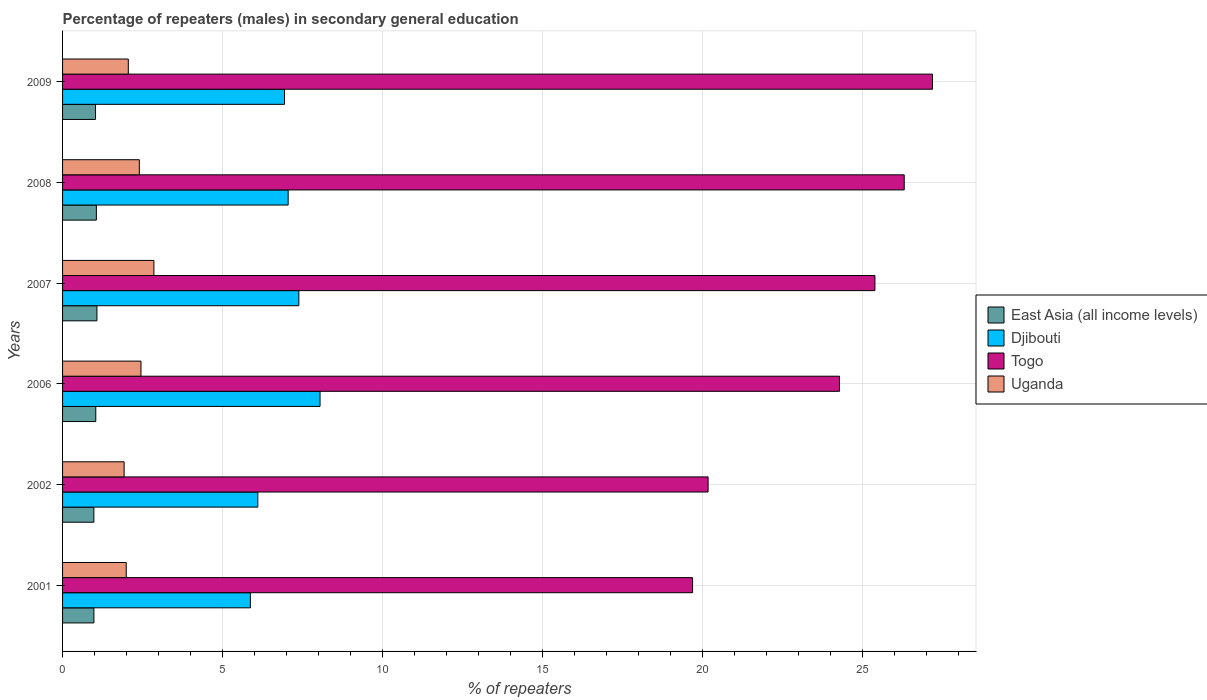How many groups of bars are there?
Offer a terse response. 6. Are the number of bars per tick equal to the number of legend labels?
Provide a short and direct response. Yes. Are the number of bars on each tick of the Y-axis equal?
Your answer should be compact. Yes. How many bars are there on the 2nd tick from the bottom?
Make the answer very short. 4. What is the percentage of male repeaters in East Asia (all income levels) in 2009?
Your response must be concise. 1.03. Across all years, what is the maximum percentage of male repeaters in Togo?
Ensure brevity in your answer.  27.2. Across all years, what is the minimum percentage of male repeaters in Djibouti?
Provide a succinct answer. 5.87. In which year was the percentage of male repeaters in Uganda maximum?
Provide a succinct answer. 2007. What is the total percentage of male repeaters in Togo in the graph?
Provide a short and direct response. 143.08. What is the difference between the percentage of male repeaters in East Asia (all income levels) in 2002 and that in 2006?
Provide a succinct answer. -0.06. What is the difference between the percentage of male repeaters in Togo in 2007 and the percentage of male repeaters in Uganda in 2001?
Offer a very short reply. 23.41. What is the average percentage of male repeaters in Uganda per year?
Your answer should be compact. 2.28. In the year 2001, what is the difference between the percentage of male repeaters in Djibouti and percentage of male repeaters in Uganda?
Offer a very short reply. 3.88. In how many years, is the percentage of male repeaters in Djibouti greater than 1 %?
Give a very brief answer. 6. What is the ratio of the percentage of male repeaters in East Asia (all income levels) in 2001 to that in 2006?
Make the answer very short. 0.94. What is the difference between the highest and the second highest percentage of male repeaters in East Asia (all income levels)?
Your answer should be compact. 0.02. What is the difference between the highest and the lowest percentage of male repeaters in Uganda?
Your response must be concise. 0.93. What does the 1st bar from the top in 2008 represents?
Ensure brevity in your answer.  Uganda. What does the 4th bar from the bottom in 2002 represents?
Make the answer very short. Uganda. Is it the case that in every year, the sum of the percentage of male repeaters in East Asia (all income levels) and percentage of male repeaters in Uganda is greater than the percentage of male repeaters in Togo?
Provide a succinct answer. No. How many bars are there?
Give a very brief answer. 24. What is the difference between two consecutive major ticks on the X-axis?
Your answer should be very brief. 5. Are the values on the major ticks of X-axis written in scientific E-notation?
Your response must be concise. No. Does the graph contain any zero values?
Provide a short and direct response. No. Does the graph contain grids?
Give a very brief answer. Yes. Where does the legend appear in the graph?
Keep it short and to the point. Center right. How are the legend labels stacked?
Offer a terse response. Vertical. What is the title of the graph?
Your response must be concise. Percentage of repeaters (males) in secondary general education. Does "India" appear as one of the legend labels in the graph?
Your response must be concise. No. What is the label or title of the X-axis?
Give a very brief answer. % of repeaters. What is the % of repeaters in East Asia (all income levels) in 2001?
Offer a very short reply. 0.98. What is the % of repeaters of Djibouti in 2001?
Your answer should be compact. 5.87. What is the % of repeaters of Togo in 2001?
Your response must be concise. 19.7. What is the % of repeaters in Uganda in 2001?
Provide a succinct answer. 1.99. What is the % of repeaters in East Asia (all income levels) in 2002?
Your answer should be very brief. 0.98. What is the % of repeaters in Djibouti in 2002?
Make the answer very short. 6.1. What is the % of repeaters of Togo in 2002?
Provide a short and direct response. 20.18. What is the % of repeaters of Uganda in 2002?
Your answer should be compact. 1.92. What is the % of repeaters of East Asia (all income levels) in 2006?
Provide a short and direct response. 1.04. What is the % of repeaters in Djibouti in 2006?
Make the answer very short. 8.05. What is the % of repeaters in Togo in 2006?
Make the answer very short. 24.29. What is the % of repeaters of Uganda in 2006?
Provide a short and direct response. 2.45. What is the % of repeaters of East Asia (all income levels) in 2007?
Provide a succinct answer. 1.07. What is the % of repeaters in Djibouti in 2007?
Make the answer very short. 7.39. What is the % of repeaters of Togo in 2007?
Your answer should be compact. 25.4. What is the % of repeaters in Uganda in 2007?
Provide a succinct answer. 2.86. What is the % of repeaters of East Asia (all income levels) in 2008?
Give a very brief answer. 1.06. What is the % of repeaters in Djibouti in 2008?
Offer a terse response. 7.05. What is the % of repeaters in Togo in 2008?
Your answer should be compact. 26.31. What is the % of repeaters in Uganda in 2008?
Your response must be concise. 2.4. What is the % of repeaters in East Asia (all income levels) in 2009?
Make the answer very short. 1.03. What is the % of repeaters in Djibouti in 2009?
Your response must be concise. 6.94. What is the % of repeaters in Togo in 2009?
Keep it short and to the point. 27.2. What is the % of repeaters of Uganda in 2009?
Ensure brevity in your answer.  2.06. Across all years, what is the maximum % of repeaters in East Asia (all income levels)?
Provide a succinct answer. 1.07. Across all years, what is the maximum % of repeaters in Djibouti?
Your response must be concise. 8.05. Across all years, what is the maximum % of repeaters in Togo?
Give a very brief answer. 27.2. Across all years, what is the maximum % of repeaters in Uganda?
Keep it short and to the point. 2.86. Across all years, what is the minimum % of repeaters in East Asia (all income levels)?
Your answer should be very brief. 0.98. Across all years, what is the minimum % of repeaters of Djibouti?
Your answer should be compact. 5.87. Across all years, what is the minimum % of repeaters in Togo?
Give a very brief answer. 19.7. Across all years, what is the minimum % of repeaters in Uganda?
Give a very brief answer. 1.92. What is the total % of repeaters in East Asia (all income levels) in the graph?
Your answer should be very brief. 6.16. What is the total % of repeaters of Djibouti in the graph?
Provide a succinct answer. 41.41. What is the total % of repeaters in Togo in the graph?
Give a very brief answer. 143.08. What is the total % of repeaters in Uganda in the graph?
Offer a terse response. 13.68. What is the difference between the % of repeaters in East Asia (all income levels) in 2001 and that in 2002?
Offer a terse response. 0. What is the difference between the % of repeaters of Djibouti in 2001 and that in 2002?
Offer a terse response. -0.23. What is the difference between the % of repeaters in Togo in 2001 and that in 2002?
Make the answer very short. -0.48. What is the difference between the % of repeaters in Uganda in 2001 and that in 2002?
Make the answer very short. 0.07. What is the difference between the % of repeaters of East Asia (all income levels) in 2001 and that in 2006?
Your response must be concise. -0.06. What is the difference between the % of repeaters of Djibouti in 2001 and that in 2006?
Keep it short and to the point. -2.18. What is the difference between the % of repeaters in Togo in 2001 and that in 2006?
Your response must be concise. -4.59. What is the difference between the % of repeaters of Uganda in 2001 and that in 2006?
Your answer should be very brief. -0.46. What is the difference between the % of repeaters in East Asia (all income levels) in 2001 and that in 2007?
Your response must be concise. -0.1. What is the difference between the % of repeaters of Djibouti in 2001 and that in 2007?
Provide a short and direct response. -1.51. What is the difference between the % of repeaters in Togo in 2001 and that in 2007?
Provide a short and direct response. -5.7. What is the difference between the % of repeaters of Uganda in 2001 and that in 2007?
Ensure brevity in your answer.  -0.87. What is the difference between the % of repeaters in East Asia (all income levels) in 2001 and that in 2008?
Your answer should be very brief. -0.08. What is the difference between the % of repeaters of Djibouti in 2001 and that in 2008?
Provide a succinct answer. -1.18. What is the difference between the % of repeaters in Togo in 2001 and that in 2008?
Keep it short and to the point. -6.62. What is the difference between the % of repeaters in Uganda in 2001 and that in 2008?
Keep it short and to the point. -0.41. What is the difference between the % of repeaters of East Asia (all income levels) in 2001 and that in 2009?
Your answer should be compact. -0.05. What is the difference between the % of repeaters of Djibouti in 2001 and that in 2009?
Your response must be concise. -1.07. What is the difference between the % of repeaters in Togo in 2001 and that in 2009?
Make the answer very short. -7.5. What is the difference between the % of repeaters of Uganda in 2001 and that in 2009?
Provide a short and direct response. -0.06. What is the difference between the % of repeaters in East Asia (all income levels) in 2002 and that in 2006?
Your response must be concise. -0.06. What is the difference between the % of repeaters in Djibouti in 2002 and that in 2006?
Ensure brevity in your answer.  -1.95. What is the difference between the % of repeaters of Togo in 2002 and that in 2006?
Give a very brief answer. -4.11. What is the difference between the % of repeaters in Uganda in 2002 and that in 2006?
Offer a terse response. -0.53. What is the difference between the % of repeaters of East Asia (all income levels) in 2002 and that in 2007?
Give a very brief answer. -0.1. What is the difference between the % of repeaters in Djibouti in 2002 and that in 2007?
Give a very brief answer. -1.28. What is the difference between the % of repeaters in Togo in 2002 and that in 2007?
Ensure brevity in your answer.  -5.22. What is the difference between the % of repeaters of Uganda in 2002 and that in 2007?
Offer a very short reply. -0.93. What is the difference between the % of repeaters in East Asia (all income levels) in 2002 and that in 2008?
Give a very brief answer. -0.08. What is the difference between the % of repeaters in Djibouti in 2002 and that in 2008?
Your answer should be compact. -0.95. What is the difference between the % of repeaters of Togo in 2002 and that in 2008?
Keep it short and to the point. -6.13. What is the difference between the % of repeaters in Uganda in 2002 and that in 2008?
Make the answer very short. -0.47. What is the difference between the % of repeaters in East Asia (all income levels) in 2002 and that in 2009?
Provide a short and direct response. -0.05. What is the difference between the % of repeaters of Djibouti in 2002 and that in 2009?
Your response must be concise. -0.84. What is the difference between the % of repeaters of Togo in 2002 and that in 2009?
Offer a terse response. -7.02. What is the difference between the % of repeaters in Uganda in 2002 and that in 2009?
Offer a very short reply. -0.13. What is the difference between the % of repeaters in East Asia (all income levels) in 2006 and that in 2007?
Your answer should be very brief. -0.04. What is the difference between the % of repeaters of Djibouti in 2006 and that in 2007?
Ensure brevity in your answer.  0.66. What is the difference between the % of repeaters in Togo in 2006 and that in 2007?
Give a very brief answer. -1.11. What is the difference between the % of repeaters of Uganda in 2006 and that in 2007?
Ensure brevity in your answer.  -0.4. What is the difference between the % of repeaters in East Asia (all income levels) in 2006 and that in 2008?
Your response must be concise. -0.02. What is the difference between the % of repeaters of Togo in 2006 and that in 2008?
Keep it short and to the point. -2.02. What is the difference between the % of repeaters in Uganda in 2006 and that in 2008?
Your answer should be very brief. 0.05. What is the difference between the % of repeaters of East Asia (all income levels) in 2006 and that in 2009?
Give a very brief answer. 0.01. What is the difference between the % of repeaters in Djibouti in 2006 and that in 2009?
Offer a terse response. 1.11. What is the difference between the % of repeaters in Togo in 2006 and that in 2009?
Your answer should be very brief. -2.91. What is the difference between the % of repeaters in Uganda in 2006 and that in 2009?
Make the answer very short. 0.4. What is the difference between the % of repeaters in East Asia (all income levels) in 2007 and that in 2008?
Provide a short and direct response. 0.02. What is the difference between the % of repeaters in Djibouti in 2007 and that in 2008?
Your answer should be compact. 0.33. What is the difference between the % of repeaters of Togo in 2007 and that in 2008?
Ensure brevity in your answer.  -0.92. What is the difference between the % of repeaters in Uganda in 2007 and that in 2008?
Make the answer very short. 0.46. What is the difference between the % of repeaters in East Asia (all income levels) in 2007 and that in 2009?
Give a very brief answer. 0.04. What is the difference between the % of repeaters in Djibouti in 2007 and that in 2009?
Give a very brief answer. 0.45. What is the difference between the % of repeaters in Togo in 2007 and that in 2009?
Keep it short and to the point. -1.8. What is the difference between the % of repeaters of Uganda in 2007 and that in 2009?
Provide a short and direct response. 0.8. What is the difference between the % of repeaters in East Asia (all income levels) in 2008 and that in 2009?
Your answer should be very brief. 0.03. What is the difference between the % of repeaters of Djibouti in 2008 and that in 2009?
Provide a succinct answer. 0.11. What is the difference between the % of repeaters of Togo in 2008 and that in 2009?
Make the answer very short. -0.88. What is the difference between the % of repeaters in Uganda in 2008 and that in 2009?
Your answer should be very brief. 0.34. What is the difference between the % of repeaters in East Asia (all income levels) in 2001 and the % of repeaters in Djibouti in 2002?
Your answer should be very brief. -5.13. What is the difference between the % of repeaters in East Asia (all income levels) in 2001 and the % of repeaters in Togo in 2002?
Give a very brief answer. -19.2. What is the difference between the % of repeaters of East Asia (all income levels) in 2001 and the % of repeaters of Uganda in 2002?
Provide a short and direct response. -0.95. What is the difference between the % of repeaters of Djibouti in 2001 and the % of repeaters of Togo in 2002?
Your answer should be very brief. -14.31. What is the difference between the % of repeaters of Djibouti in 2001 and the % of repeaters of Uganda in 2002?
Make the answer very short. 3.95. What is the difference between the % of repeaters of Togo in 2001 and the % of repeaters of Uganda in 2002?
Your response must be concise. 17.77. What is the difference between the % of repeaters of East Asia (all income levels) in 2001 and the % of repeaters of Djibouti in 2006?
Keep it short and to the point. -7.07. What is the difference between the % of repeaters in East Asia (all income levels) in 2001 and the % of repeaters in Togo in 2006?
Offer a terse response. -23.31. What is the difference between the % of repeaters in East Asia (all income levels) in 2001 and the % of repeaters in Uganda in 2006?
Offer a very short reply. -1.47. What is the difference between the % of repeaters in Djibouti in 2001 and the % of repeaters in Togo in 2006?
Keep it short and to the point. -18.42. What is the difference between the % of repeaters of Djibouti in 2001 and the % of repeaters of Uganda in 2006?
Keep it short and to the point. 3.42. What is the difference between the % of repeaters in Togo in 2001 and the % of repeaters in Uganda in 2006?
Offer a very short reply. 17.25. What is the difference between the % of repeaters in East Asia (all income levels) in 2001 and the % of repeaters in Djibouti in 2007?
Your response must be concise. -6.41. What is the difference between the % of repeaters of East Asia (all income levels) in 2001 and the % of repeaters of Togo in 2007?
Your response must be concise. -24.42. What is the difference between the % of repeaters of East Asia (all income levels) in 2001 and the % of repeaters of Uganda in 2007?
Your answer should be compact. -1.88. What is the difference between the % of repeaters in Djibouti in 2001 and the % of repeaters in Togo in 2007?
Offer a terse response. -19.53. What is the difference between the % of repeaters of Djibouti in 2001 and the % of repeaters of Uganda in 2007?
Make the answer very short. 3.02. What is the difference between the % of repeaters in Togo in 2001 and the % of repeaters in Uganda in 2007?
Your answer should be compact. 16.84. What is the difference between the % of repeaters of East Asia (all income levels) in 2001 and the % of repeaters of Djibouti in 2008?
Your response must be concise. -6.07. What is the difference between the % of repeaters in East Asia (all income levels) in 2001 and the % of repeaters in Togo in 2008?
Make the answer very short. -25.33. What is the difference between the % of repeaters in East Asia (all income levels) in 2001 and the % of repeaters in Uganda in 2008?
Ensure brevity in your answer.  -1.42. What is the difference between the % of repeaters of Djibouti in 2001 and the % of repeaters of Togo in 2008?
Your answer should be compact. -20.44. What is the difference between the % of repeaters in Djibouti in 2001 and the % of repeaters in Uganda in 2008?
Give a very brief answer. 3.47. What is the difference between the % of repeaters of Togo in 2001 and the % of repeaters of Uganda in 2008?
Your answer should be very brief. 17.3. What is the difference between the % of repeaters in East Asia (all income levels) in 2001 and the % of repeaters in Djibouti in 2009?
Your answer should be compact. -5.96. What is the difference between the % of repeaters in East Asia (all income levels) in 2001 and the % of repeaters in Togo in 2009?
Offer a terse response. -26.22. What is the difference between the % of repeaters in East Asia (all income levels) in 2001 and the % of repeaters in Uganda in 2009?
Offer a very short reply. -1.08. What is the difference between the % of repeaters in Djibouti in 2001 and the % of repeaters in Togo in 2009?
Provide a short and direct response. -21.33. What is the difference between the % of repeaters of Djibouti in 2001 and the % of repeaters of Uganda in 2009?
Give a very brief answer. 3.82. What is the difference between the % of repeaters of Togo in 2001 and the % of repeaters of Uganda in 2009?
Provide a short and direct response. 17.64. What is the difference between the % of repeaters in East Asia (all income levels) in 2002 and the % of repeaters in Djibouti in 2006?
Your response must be concise. -7.07. What is the difference between the % of repeaters of East Asia (all income levels) in 2002 and the % of repeaters of Togo in 2006?
Your response must be concise. -23.31. What is the difference between the % of repeaters in East Asia (all income levels) in 2002 and the % of repeaters in Uganda in 2006?
Offer a terse response. -1.47. What is the difference between the % of repeaters of Djibouti in 2002 and the % of repeaters of Togo in 2006?
Give a very brief answer. -18.19. What is the difference between the % of repeaters in Djibouti in 2002 and the % of repeaters in Uganda in 2006?
Keep it short and to the point. 3.65. What is the difference between the % of repeaters in Togo in 2002 and the % of repeaters in Uganda in 2006?
Your response must be concise. 17.73. What is the difference between the % of repeaters in East Asia (all income levels) in 2002 and the % of repeaters in Djibouti in 2007?
Keep it short and to the point. -6.41. What is the difference between the % of repeaters of East Asia (all income levels) in 2002 and the % of repeaters of Togo in 2007?
Your response must be concise. -24.42. What is the difference between the % of repeaters in East Asia (all income levels) in 2002 and the % of repeaters in Uganda in 2007?
Ensure brevity in your answer.  -1.88. What is the difference between the % of repeaters in Djibouti in 2002 and the % of repeaters in Togo in 2007?
Your answer should be compact. -19.29. What is the difference between the % of repeaters of Djibouti in 2002 and the % of repeaters of Uganda in 2007?
Give a very brief answer. 3.25. What is the difference between the % of repeaters of Togo in 2002 and the % of repeaters of Uganda in 2007?
Provide a succinct answer. 17.33. What is the difference between the % of repeaters of East Asia (all income levels) in 2002 and the % of repeaters of Djibouti in 2008?
Ensure brevity in your answer.  -6.07. What is the difference between the % of repeaters in East Asia (all income levels) in 2002 and the % of repeaters in Togo in 2008?
Give a very brief answer. -25.34. What is the difference between the % of repeaters in East Asia (all income levels) in 2002 and the % of repeaters in Uganda in 2008?
Offer a very short reply. -1.42. What is the difference between the % of repeaters of Djibouti in 2002 and the % of repeaters of Togo in 2008?
Ensure brevity in your answer.  -20.21. What is the difference between the % of repeaters of Djibouti in 2002 and the % of repeaters of Uganda in 2008?
Your answer should be very brief. 3.7. What is the difference between the % of repeaters of Togo in 2002 and the % of repeaters of Uganda in 2008?
Provide a short and direct response. 17.78. What is the difference between the % of repeaters in East Asia (all income levels) in 2002 and the % of repeaters in Djibouti in 2009?
Your answer should be compact. -5.96. What is the difference between the % of repeaters in East Asia (all income levels) in 2002 and the % of repeaters in Togo in 2009?
Your answer should be very brief. -26.22. What is the difference between the % of repeaters of East Asia (all income levels) in 2002 and the % of repeaters of Uganda in 2009?
Your answer should be very brief. -1.08. What is the difference between the % of repeaters of Djibouti in 2002 and the % of repeaters of Togo in 2009?
Provide a succinct answer. -21.09. What is the difference between the % of repeaters in Djibouti in 2002 and the % of repeaters in Uganda in 2009?
Your answer should be very brief. 4.05. What is the difference between the % of repeaters of Togo in 2002 and the % of repeaters of Uganda in 2009?
Keep it short and to the point. 18.13. What is the difference between the % of repeaters of East Asia (all income levels) in 2006 and the % of repeaters of Djibouti in 2007?
Offer a very short reply. -6.35. What is the difference between the % of repeaters of East Asia (all income levels) in 2006 and the % of repeaters of Togo in 2007?
Your answer should be very brief. -24.36. What is the difference between the % of repeaters of East Asia (all income levels) in 2006 and the % of repeaters of Uganda in 2007?
Your answer should be compact. -1.82. What is the difference between the % of repeaters of Djibouti in 2006 and the % of repeaters of Togo in 2007?
Your response must be concise. -17.35. What is the difference between the % of repeaters in Djibouti in 2006 and the % of repeaters in Uganda in 2007?
Your response must be concise. 5.19. What is the difference between the % of repeaters of Togo in 2006 and the % of repeaters of Uganda in 2007?
Keep it short and to the point. 21.43. What is the difference between the % of repeaters of East Asia (all income levels) in 2006 and the % of repeaters of Djibouti in 2008?
Ensure brevity in your answer.  -6.01. What is the difference between the % of repeaters of East Asia (all income levels) in 2006 and the % of repeaters of Togo in 2008?
Make the answer very short. -25.28. What is the difference between the % of repeaters of East Asia (all income levels) in 2006 and the % of repeaters of Uganda in 2008?
Make the answer very short. -1.36. What is the difference between the % of repeaters of Djibouti in 2006 and the % of repeaters of Togo in 2008?
Your answer should be very brief. -18.26. What is the difference between the % of repeaters of Djibouti in 2006 and the % of repeaters of Uganda in 2008?
Keep it short and to the point. 5.65. What is the difference between the % of repeaters of Togo in 2006 and the % of repeaters of Uganda in 2008?
Make the answer very short. 21.89. What is the difference between the % of repeaters of East Asia (all income levels) in 2006 and the % of repeaters of Djibouti in 2009?
Offer a terse response. -5.9. What is the difference between the % of repeaters in East Asia (all income levels) in 2006 and the % of repeaters in Togo in 2009?
Provide a succinct answer. -26.16. What is the difference between the % of repeaters of East Asia (all income levels) in 2006 and the % of repeaters of Uganda in 2009?
Your response must be concise. -1.02. What is the difference between the % of repeaters in Djibouti in 2006 and the % of repeaters in Togo in 2009?
Keep it short and to the point. -19.15. What is the difference between the % of repeaters of Djibouti in 2006 and the % of repeaters of Uganda in 2009?
Ensure brevity in your answer.  5.99. What is the difference between the % of repeaters in Togo in 2006 and the % of repeaters in Uganda in 2009?
Keep it short and to the point. 22.23. What is the difference between the % of repeaters of East Asia (all income levels) in 2007 and the % of repeaters of Djibouti in 2008?
Your response must be concise. -5.98. What is the difference between the % of repeaters in East Asia (all income levels) in 2007 and the % of repeaters in Togo in 2008?
Offer a terse response. -25.24. What is the difference between the % of repeaters in East Asia (all income levels) in 2007 and the % of repeaters in Uganda in 2008?
Make the answer very short. -1.33. What is the difference between the % of repeaters of Djibouti in 2007 and the % of repeaters of Togo in 2008?
Your answer should be very brief. -18.93. What is the difference between the % of repeaters of Djibouti in 2007 and the % of repeaters of Uganda in 2008?
Keep it short and to the point. 4.99. What is the difference between the % of repeaters of Togo in 2007 and the % of repeaters of Uganda in 2008?
Offer a very short reply. 23. What is the difference between the % of repeaters in East Asia (all income levels) in 2007 and the % of repeaters in Djibouti in 2009?
Provide a succinct answer. -5.87. What is the difference between the % of repeaters in East Asia (all income levels) in 2007 and the % of repeaters in Togo in 2009?
Your answer should be very brief. -26.12. What is the difference between the % of repeaters of East Asia (all income levels) in 2007 and the % of repeaters of Uganda in 2009?
Your answer should be compact. -0.98. What is the difference between the % of repeaters in Djibouti in 2007 and the % of repeaters in Togo in 2009?
Your response must be concise. -19.81. What is the difference between the % of repeaters of Djibouti in 2007 and the % of repeaters of Uganda in 2009?
Your response must be concise. 5.33. What is the difference between the % of repeaters in Togo in 2007 and the % of repeaters in Uganda in 2009?
Your answer should be compact. 23.34. What is the difference between the % of repeaters of East Asia (all income levels) in 2008 and the % of repeaters of Djibouti in 2009?
Offer a very short reply. -5.88. What is the difference between the % of repeaters of East Asia (all income levels) in 2008 and the % of repeaters of Togo in 2009?
Offer a terse response. -26.14. What is the difference between the % of repeaters in East Asia (all income levels) in 2008 and the % of repeaters in Uganda in 2009?
Ensure brevity in your answer.  -1. What is the difference between the % of repeaters in Djibouti in 2008 and the % of repeaters in Togo in 2009?
Provide a short and direct response. -20.14. What is the difference between the % of repeaters in Djibouti in 2008 and the % of repeaters in Uganda in 2009?
Provide a succinct answer. 5. What is the difference between the % of repeaters in Togo in 2008 and the % of repeaters in Uganda in 2009?
Your response must be concise. 24.26. What is the average % of repeaters of East Asia (all income levels) per year?
Ensure brevity in your answer.  1.03. What is the average % of repeaters in Djibouti per year?
Keep it short and to the point. 6.9. What is the average % of repeaters in Togo per year?
Your answer should be compact. 23.85. What is the average % of repeaters of Uganda per year?
Make the answer very short. 2.28. In the year 2001, what is the difference between the % of repeaters in East Asia (all income levels) and % of repeaters in Djibouti?
Ensure brevity in your answer.  -4.89. In the year 2001, what is the difference between the % of repeaters of East Asia (all income levels) and % of repeaters of Togo?
Keep it short and to the point. -18.72. In the year 2001, what is the difference between the % of repeaters of East Asia (all income levels) and % of repeaters of Uganda?
Offer a very short reply. -1.01. In the year 2001, what is the difference between the % of repeaters in Djibouti and % of repeaters in Togo?
Give a very brief answer. -13.82. In the year 2001, what is the difference between the % of repeaters of Djibouti and % of repeaters of Uganda?
Your answer should be very brief. 3.88. In the year 2001, what is the difference between the % of repeaters of Togo and % of repeaters of Uganda?
Offer a terse response. 17.71. In the year 2002, what is the difference between the % of repeaters in East Asia (all income levels) and % of repeaters in Djibouti?
Your response must be concise. -5.13. In the year 2002, what is the difference between the % of repeaters of East Asia (all income levels) and % of repeaters of Togo?
Your answer should be compact. -19.2. In the year 2002, what is the difference between the % of repeaters in East Asia (all income levels) and % of repeaters in Uganda?
Give a very brief answer. -0.95. In the year 2002, what is the difference between the % of repeaters of Djibouti and % of repeaters of Togo?
Provide a succinct answer. -14.08. In the year 2002, what is the difference between the % of repeaters in Djibouti and % of repeaters in Uganda?
Give a very brief answer. 4.18. In the year 2002, what is the difference between the % of repeaters in Togo and % of repeaters in Uganda?
Provide a short and direct response. 18.26. In the year 2006, what is the difference between the % of repeaters of East Asia (all income levels) and % of repeaters of Djibouti?
Make the answer very short. -7.01. In the year 2006, what is the difference between the % of repeaters in East Asia (all income levels) and % of repeaters in Togo?
Your response must be concise. -23.25. In the year 2006, what is the difference between the % of repeaters of East Asia (all income levels) and % of repeaters of Uganda?
Provide a short and direct response. -1.41. In the year 2006, what is the difference between the % of repeaters in Djibouti and % of repeaters in Togo?
Provide a succinct answer. -16.24. In the year 2006, what is the difference between the % of repeaters of Djibouti and % of repeaters of Uganda?
Offer a terse response. 5.6. In the year 2006, what is the difference between the % of repeaters in Togo and % of repeaters in Uganda?
Offer a very short reply. 21.84. In the year 2007, what is the difference between the % of repeaters of East Asia (all income levels) and % of repeaters of Djibouti?
Ensure brevity in your answer.  -6.31. In the year 2007, what is the difference between the % of repeaters in East Asia (all income levels) and % of repeaters in Togo?
Offer a terse response. -24.32. In the year 2007, what is the difference between the % of repeaters in East Asia (all income levels) and % of repeaters in Uganda?
Your answer should be compact. -1.78. In the year 2007, what is the difference between the % of repeaters in Djibouti and % of repeaters in Togo?
Give a very brief answer. -18.01. In the year 2007, what is the difference between the % of repeaters in Djibouti and % of repeaters in Uganda?
Offer a terse response. 4.53. In the year 2007, what is the difference between the % of repeaters in Togo and % of repeaters in Uganda?
Your answer should be compact. 22.54. In the year 2008, what is the difference between the % of repeaters of East Asia (all income levels) and % of repeaters of Djibouti?
Your response must be concise. -6. In the year 2008, what is the difference between the % of repeaters of East Asia (all income levels) and % of repeaters of Togo?
Give a very brief answer. -25.26. In the year 2008, what is the difference between the % of repeaters in East Asia (all income levels) and % of repeaters in Uganda?
Your answer should be compact. -1.34. In the year 2008, what is the difference between the % of repeaters in Djibouti and % of repeaters in Togo?
Provide a short and direct response. -19.26. In the year 2008, what is the difference between the % of repeaters in Djibouti and % of repeaters in Uganda?
Give a very brief answer. 4.65. In the year 2008, what is the difference between the % of repeaters in Togo and % of repeaters in Uganda?
Give a very brief answer. 23.91. In the year 2009, what is the difference between the % of repeaters in East Asia (all income levels) and % of repeaters in Djibouti?
Provide a short and direct response. -5.91. In the year 2009, what is the difference between the % of repeaters in East Asia (all income levels) and % of repeaters in Togo?
Offer a very short reply. -26.17. In the year 2009, what is the difference between the % of repeaters in East Asia (all income levels) and % of repeaters in Uganda?
Your answer should be compact. -1.02. In the year 2009, what is the difference between the % of repeaters in Djibouti and % of repeaters in Togo?
Your response must be concise. -20.26. In the year 2009, what is the difference between the % of repeaters in Djibouti and % of repeaters in Uganda?
Offer a terse response. 4.88. In the year 2009, what is the difference between the % of repeaters in Togo and % of repeaters in Uganda?
Ensure brevity in your answer.  25.14. What is the ratio of the % of repeaters of East Asia (all income levels) in 2001 to that in 2002?
Give a very brief answer. 1. What is the ratio of the % of repeaters in Djibouti in 2001 to that in 2002?
Your response must be concise. 0.96. What is the ratio of the % of repeaters of Togo in 2001 to that in 2002?
Provide a short and direct response. 0.98. What is the ratio of the % of repeaters in Uganda in 2001 to that in 2002?
Provide a short and direct response. 1.03. What is the ratio of the % of repeaters in East Asia (all income levels) in 2001 to that in 2006?
Make the answer very short. 0.94. What is the ratio of the % of repeaters of Djibouti in 2001 to that in 2006?
Keep it short and to the point. 0.73. What is the ratio of the % of repeaters of Togo in 2001 to that in 2006?
Give a very brief answer. 0.81. What is the ratio of the % of repeaters of Uganda in 2001 to that in 2006?
Offer a very short reply. 0.81. What is the ratio of the % of repeaters in East Asia (all income levels) in 2001 to that in 2007?
Your response must be concise. 0.91. What is the ratio of the % of repeaters in Djibouti in 2001 to that in 2007?
Provide a succinct answer. 0.79. What is the ratio of the % of repeaters of Togo in 2001 to that in 2007?
Ensure brevity in your answer.  0.78. What is the ratio of the % of repeaters of Uganda in 2001 to that in 2007?
Your response must be concise. 0.7. What is the ratio of the % of repeaters in East Asia (all income levels) in 2001 to that in 2008?
Give a very brief answer. 0.93. What is the ratio of the % of repeaters in Djibouti in 2001 to that in 2008?
Your answer should be compact. 0.83. What is the ratio of the % of repeaters in Togo in 2001 to that in 2008?
Your answer should be compact. 0.75. What is the ratio of the % of repeaters of Uganda in 2001 to that in 2008?
Your answer should be very brief. 0.83. What is the ratio of the % of repeaters of Djibouti in 2001 to that in 2009?
Offer a very short reply. 0.85. What is the ratio of the % of repeaters of Togo in 2001 to that in 2009?
Your answer should be very brief. 0.72. What is the ratio of the % of repeaters in Uganda in 2001 to that in 2009?
Your answer should be very brief. 0.97. What is the ratio of the % of repeaters of East Asia (all income levels) in 2002 to that in 2006?
Give a very brief answer. 0.94. What is the ratio of the % of repeaters in Djibouti in 2002 to that in 2006?
Offer a terse response. 0.76. What is the ratio of the % of repeaters of Togo in 2002 to that in 2006?
Ensure brevity in your answer.  0.83. What is the ratio of the % of repeaters of Uganda in 2002 to that in 2006?
Offer a terse response. 0.79. What is the ratio of the % of repeaters in East Asia (all income levels) in 2002 to that in 2007?
Your response must be concise. 0.91. What is the ratio of the % of repeaters in Djibouti in 2002 to that in 2007?
Your answer should be very brief. 0.83. What is the ratio of the % of repeaters of Togo in 2002 to that in 2007?
Give a very brief answer. 0.79. What is the ratio of the % of repeaters in Uganda in 2002 to that in 2007?
Provide a short and direct response. 0.67. What is the ratio of the % of repeaters of East Asia (all income levels) in 2002 to that in 2008?
Provide a short and direct response. 0.93. What is the ratio of the % of repeaters in Djibouti in 2002 to that in 2008?
Provide a succinct answer. 0.87. What is the ratio of the % of repeaters of Togo in 2002 to that in 2008?
Provide a succinct answer. 0.77. What is the ratio of the % of repeaters of Uganda in 2002 to that in 2008?
Provide a succinct answer. 0.8. What is the ratio of the % of repeaters in East Asia (all income levels) in 2002 to that in 2009?
Offer a terse response. 0.95. What is the ratio of the % of repeaters in Djibouti in 2002 to that in 2009?
Provide a succinct answer. 0.88. What is the ratio of the % of repeaters in Togo in 2002 to that in 2009?
Keep it short and to the point. 0.74. What is the ratio of the % of repeaters in Uganda in 2002 to that in 2009?
Give a very brief answer. 0.94. What is the ratio of the % of repeaters in East Asia (all income levels) in 2006 to that in 2007?
Offer a very short reply. 0.97. What is the ratio of the % of repeaters of Djibouti in 2006 to that in 2007?
Ensure brevity in your answer.  1.09. What is the ratio of the % of repeaters of Togo in 2006 to that in 2007?
Your answer should be very brief. 0.96. What is the ratio of the % of repeaters of Uganda in 2006 to that in 2007?
Keep it short and to the point. 0.86. What is the ratio of the % of repeaters in East Asia (all income levels) in 2006 to that in 2008?
Provide a short and direct response. 0.98. What is the ratio of the % of repeaters of Djibouti in 2006 to that in 2008?
Offer a very short reply. 1.14. What is the ratio of the % of repeaters in Togo in 2006 to that in 2008?
Give a very brief answer. 0.92. What is the ratio of the % of repeaters in Uganda in 2006 to that in 2008?
Your response must be concise. 1.02. What is the ratio of the % of repeaters of East Asia (all income levels) in 2006 to that in 2009?
Offer a very short reply. 1.01. What is the ratio of the % of repeaters in Djibouti in 2006 to that in 2009?
Your answer should be very brief. 1.16. What is the ratio of the % of repeaters in Togo in 2006 to that in 2009?
Offer a very short reply. 0.89. What is the ratio of the % of repeaters in Uganda in 2006 to that in 2009?
Make the answer very short. 1.19. What is the ratio of the % of repeaters of East Asia (all income levels) in 2007 to that in 2008?
Your response must be concise. 1.02. What is the ratio of the % of repeaters of Djibouti in 2007 to that in 2008?
Provide a short and direct response. 1.05. What is the ratio of the % of repeaters of Togo in 2007 to that in 2008?
Your answer should be compact. 0.97. What is the ratio of the % of repeaters of Uganda in 2007 to that in 2008?
Provide a succinct answer. 1.19. What is the ratio of the % of repeaters of East Asia (all income levels) in 2007 to that in 2009?
Provide a short and direct response. 1.04. What is the ratio of the % of repeaters of Djibouti in 2007 to that in 2009?
Offer a very short reply. 1.06. What is the ratio of the % of repeaters of Togo in 2007 to that in 2009?
Your answer should be compact. 0.93. What is the ratio of the % of repeaters in Uganda in 2007 to that in 2009?
Provide a succinct answer. 1.39. What is the ratio of the % of repeaters in East Asia (all income levels) in 2008 to that in 2009?
Offer a terse response. 1.03. What is the ratio of the % of repeaters in Djibouti in 2008 to that in 2009?
Ensure brevity in your answer.  1.02. What is the ratio of the % of repeaters of Togo in 2008 to that in 2009?
Offer a very short reply. 0.97. What is the ratio of the % of repeaters in Uganda in 2008 to that in 2009?
Keep it short and to the point. 1.17. What is the difference between the highest and the second highest % of repeaters of East Asia (all income levels)?
Provide a succinct answer. 0.02. What is the difference between the highest and the second highest % of repeaters of Djibouti?
Provide a short and direct response. 0.66. What is the difference between the highest and the second highest % of repeaters of Togo?
Ensure brevity in your answer.  0.88. What is the difference between the highest and the second highest % of repeaters of Uganda?
Provide a short and direct response. 0.4. What is the difference between the highest and the lowest % of repeaters in East Asia (all income levels)?
Offer a terse response. 0.1. What is the difference between the highest and the lowest % of repeaters of Djibouti?
Keep it short and to the point. 2.18. What is the difference between the highest and the lowest % of repeaters of Togo?
Offer a very short reply. 7.5. What is the difference between the highest and the lowest % of repeaters of Uganda?
Offer a very short reply. 0.93. 